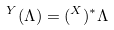Convert formula to latex. <formula><loc_0><loc_0><loc_500><loc_500>\AA ^ { Y } ( \Lambda ) = ( \AA ^ { X } ) ^ { * } \Lambda</formula> 